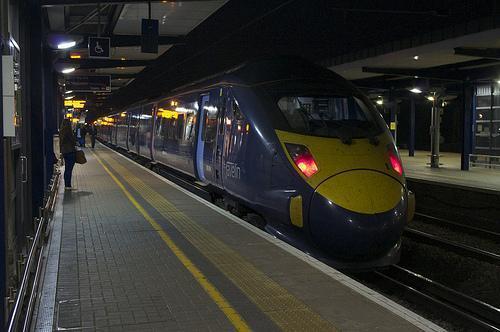How many trains are there?
Give a very brief answer. 1. How many lights are on the front of the train?
Give a very brief answer. 2. How many people are on the left side of the platform?
Give a very brief answer. 3. 